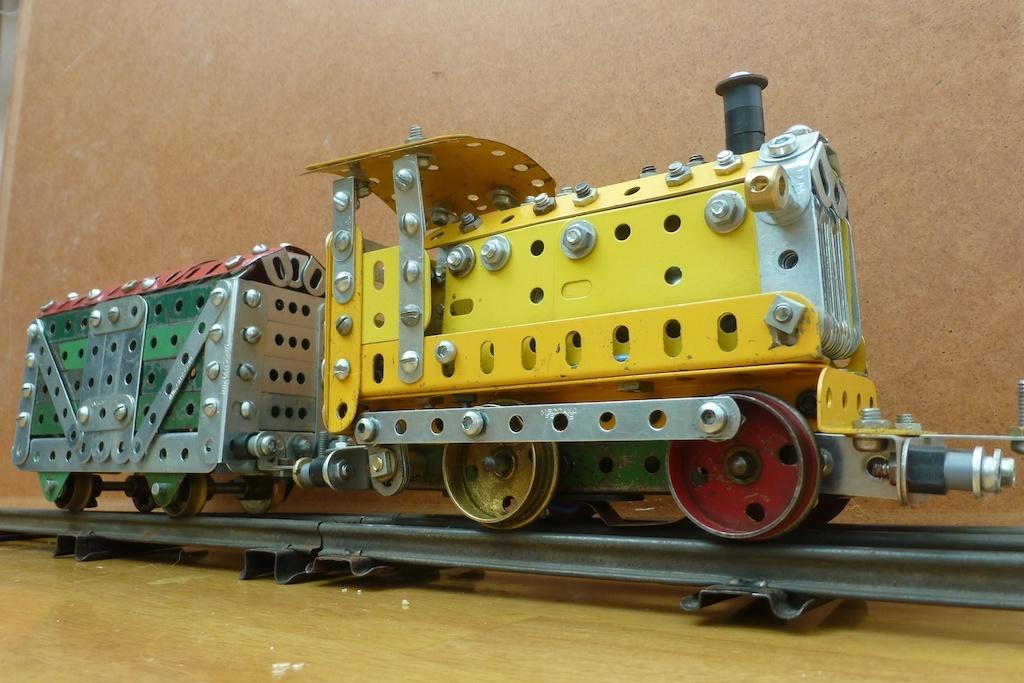What is the main subject in the middle of the image? There is a toy train present in the middle of the image. What can be seen in the background of the image? There is a wall in the background of the image. What holiday is being celebrated in the image? There is no indication of a holiday being celebrated in the image. What achievement is the toy train being recognized for in the image? The toy train is not an achiever, as it is an inanimate object and not capable of achieving anything. 